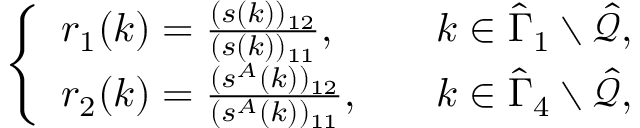<formula> <loc_0><loc_0><loc_500><loc_500>\begin{array} { r } { \left \{ \begin{array} { l l } { r _ { 1 } ( k ) = \frac { ( s ( k ) ) _ { 1 2 } } { ( s ( k ) ) _ { 1 1 } } , } & { k \in \hat { \Gamma } _ { 1 } \ \hat { \mathcal { Q } } , } \\ { r _ { 2 } ( k ) = \frac { ( s ^ { A } ( k ) ) _ { 1 2 } } { ( s ^ { A } ( k ) ) _ { 1 1 } } , \quad } & { k \in \hat { \Gamma } _ { 4 } \ \hat { \mathcal { Q } } , } \end{array} } \end{array}</formula> 